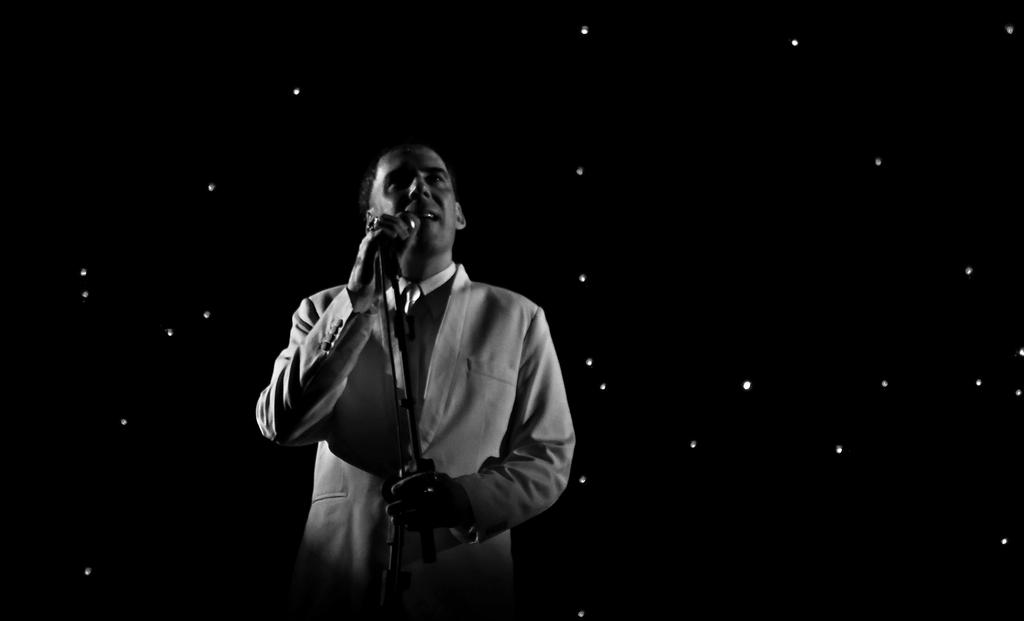What is the main subject of the image? There is a person in the image. What is the person doing in the image? The person is standing in the image. What object is the person holding in the image? The person is holding a mic in his hand. What type of pan can be seen on the coast in the image? There is no pan or coast present in the image; it features a person standing and holding a mic. What is the base of the person's support in the image? The person is standing, so there is no separate base for support visible in the image. 